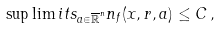Convert formula to latex. <formula><loc_0><loc_0><loc_500><loc_500>\sup \lim i t s _ { a \in \overline { \mathbb { R } } ^ { n } } n _ { f } ( x , r , a ) \leq C \, ,</formula> 